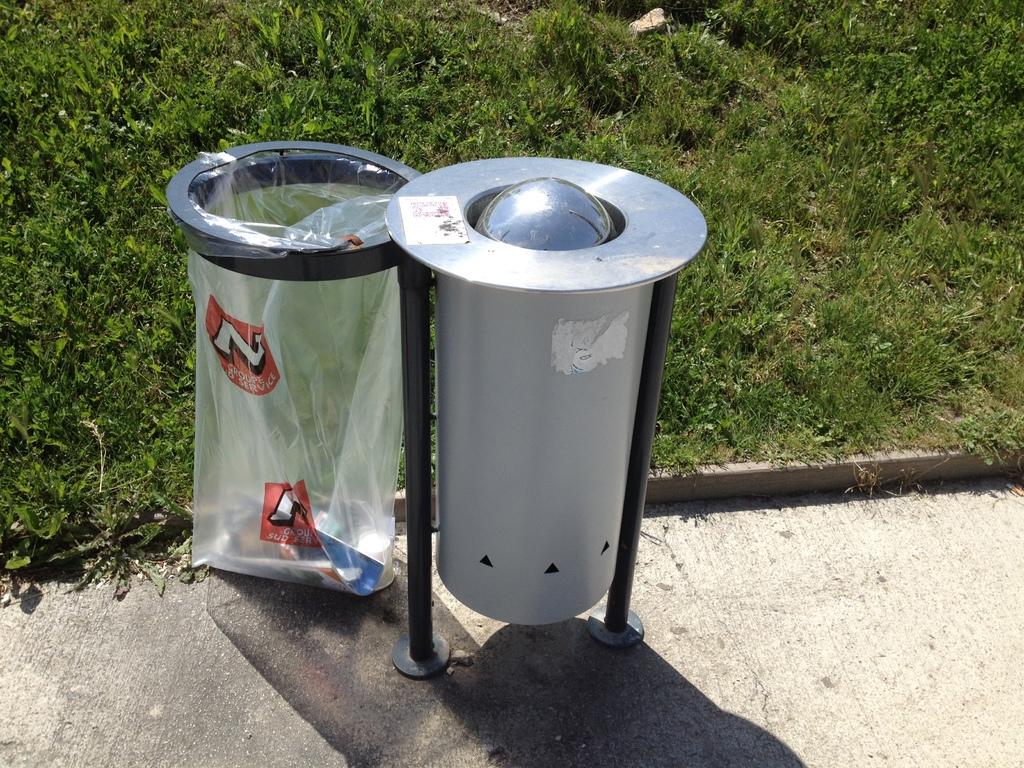What letter is on the bag?
Ensure brevity in your answer.  N. 